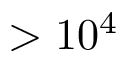<formula> <loc_0><loc_0><loc_500><loc_500>> 1 0 ^ { 4 }</formula> 